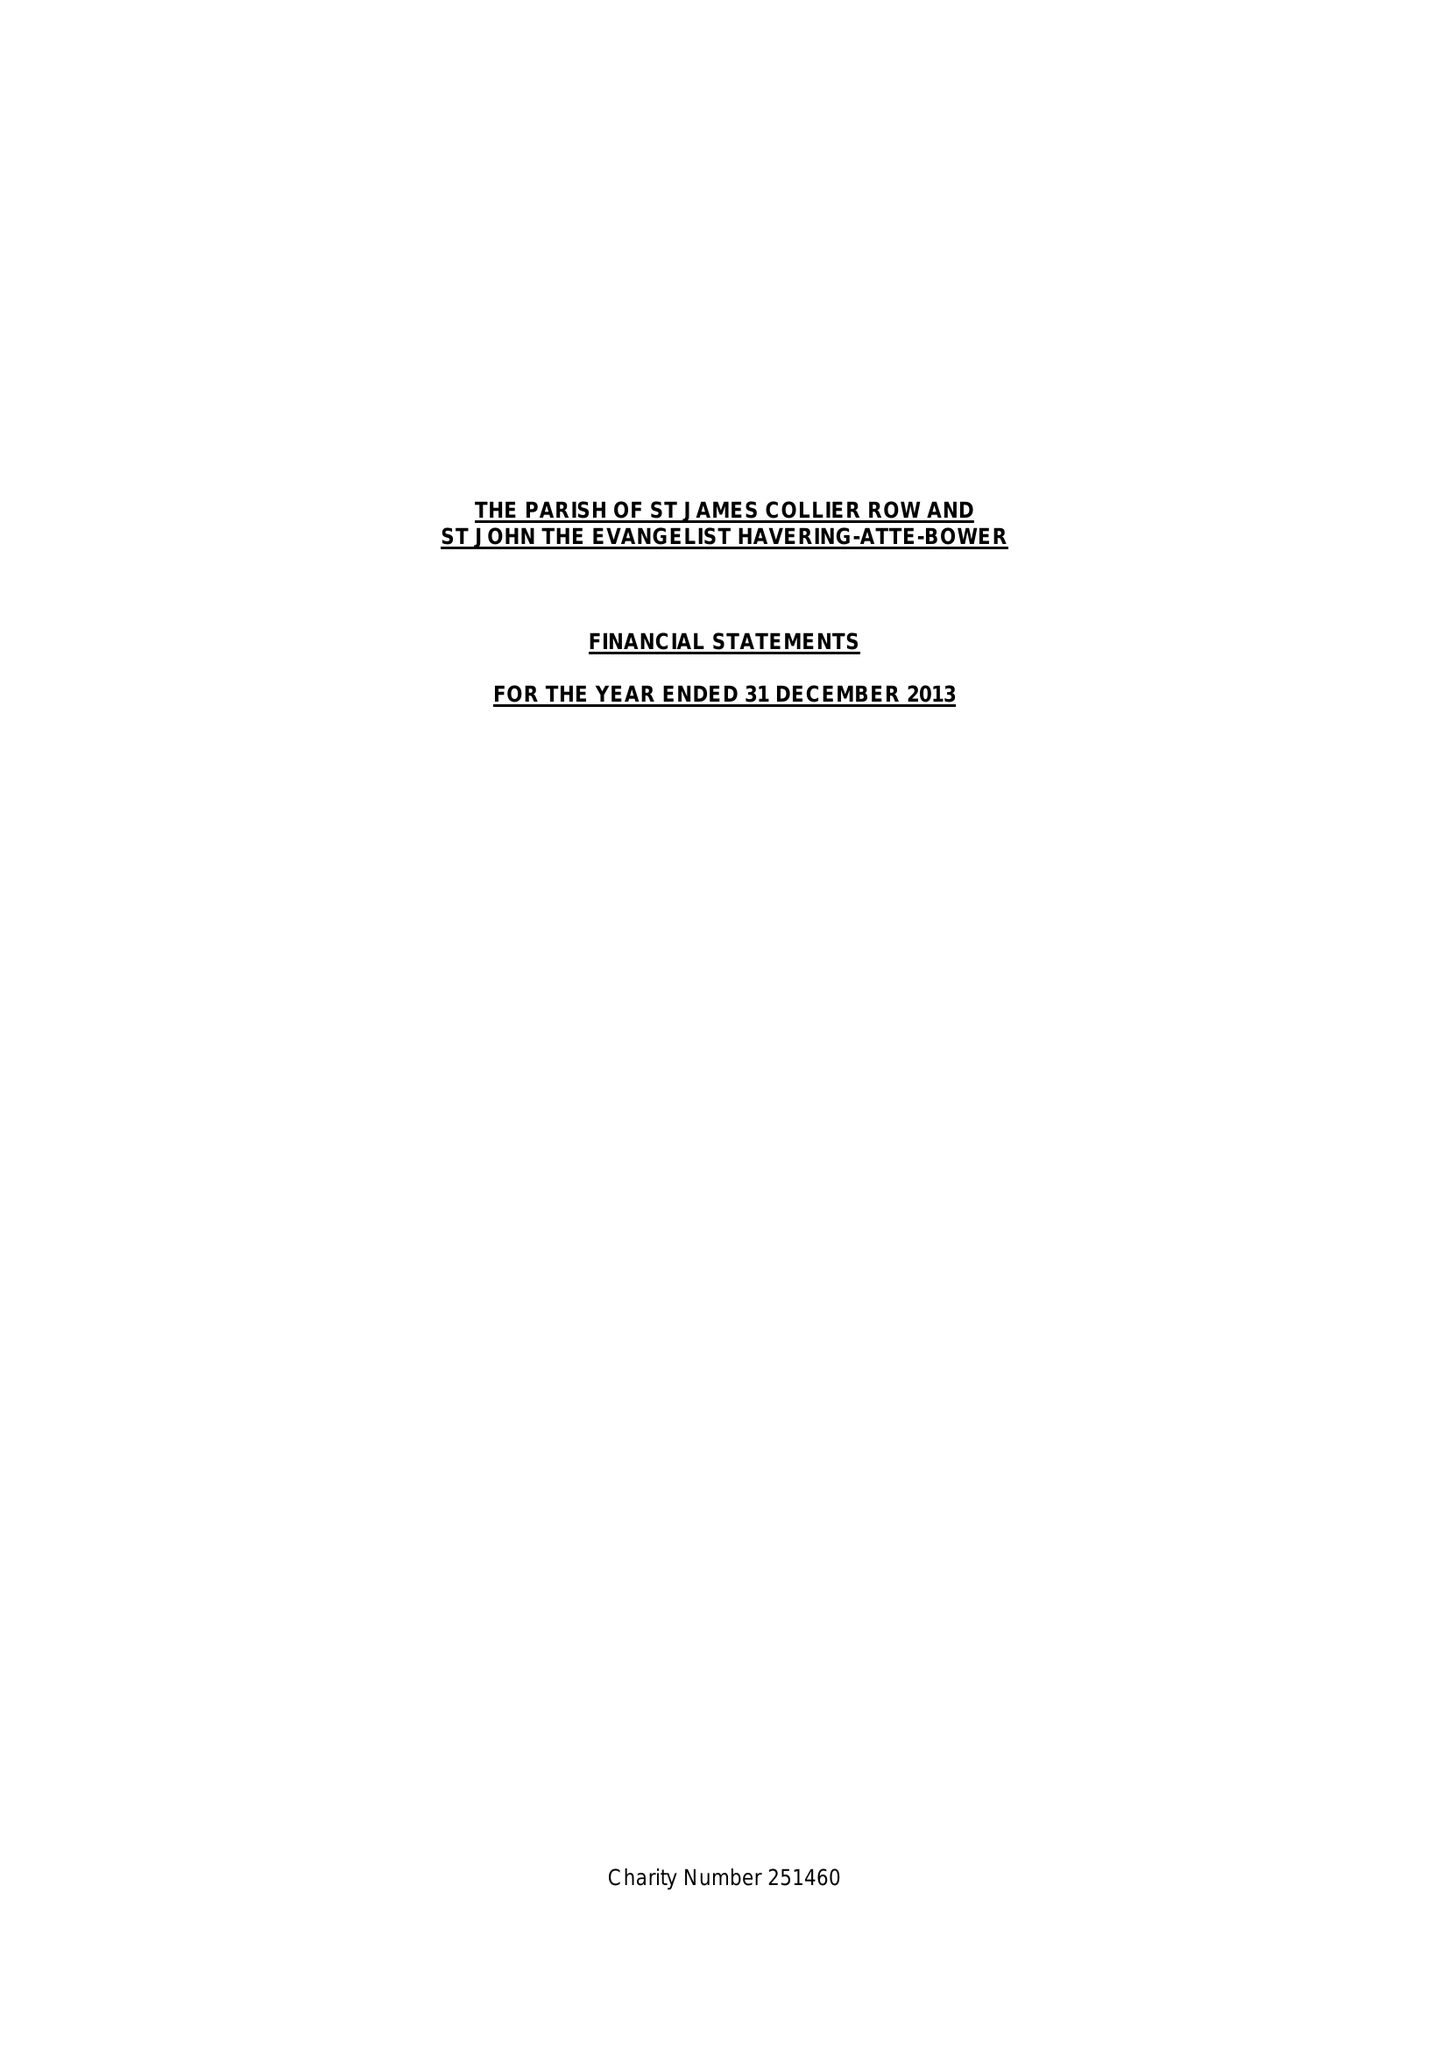What is the value for the charity_number?
Answer the question using a single word or phrase. 251460 